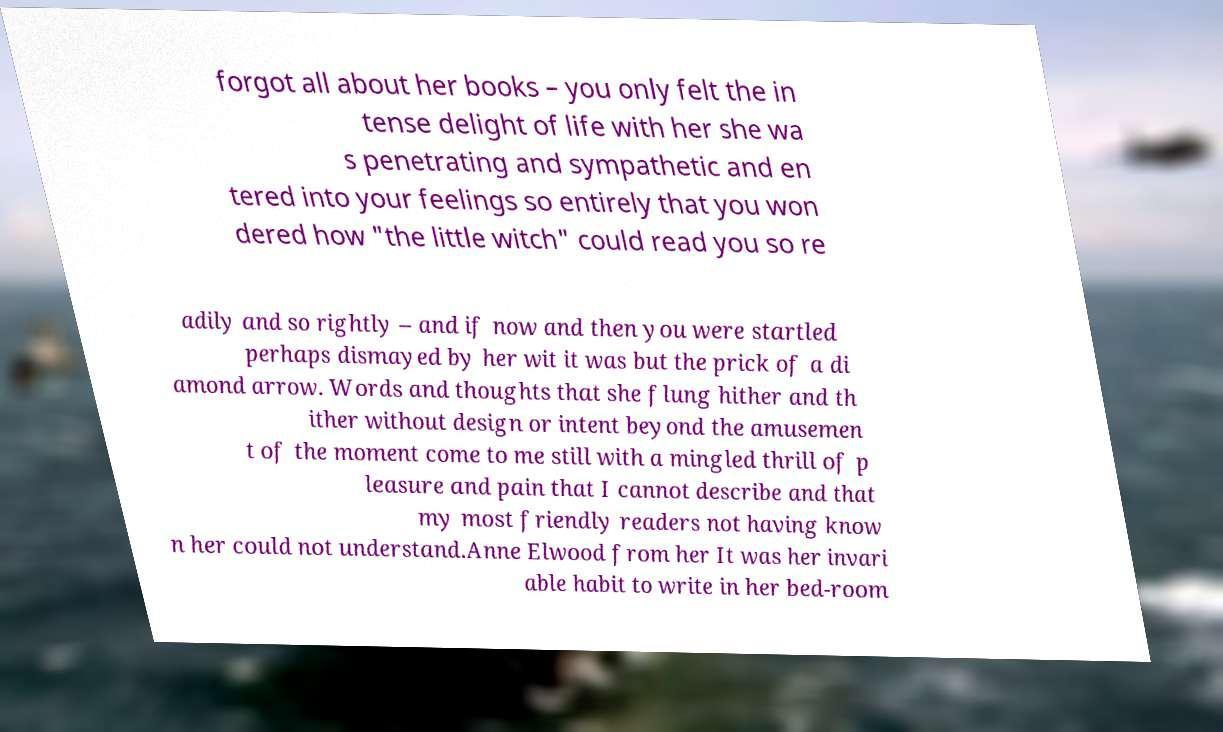Can you read and provide the text displayed in the image?This photo seems to have some interesting text. Can you extract and type it out for me? forgot all about her books – you only felt the in tense delight of life with her she wa s penetrating and sympathetic and en tered into your feelings so entirely that you won dered how "the little witch" could read you so re adily and so rightly – and if now and then you were startled perhaps dismayed by her wit it was but the prick of a di amond arrow. Words and thoughts that she flung hither and th ither without design or intent beyond the amusemen t of the moment come to me still with a mingled thrill of p leasure and pain that I cannot describe and that my most friendly readers not having know n her could not understand.Anne Elwood from her It was her invari able habit to write in her bed-room 